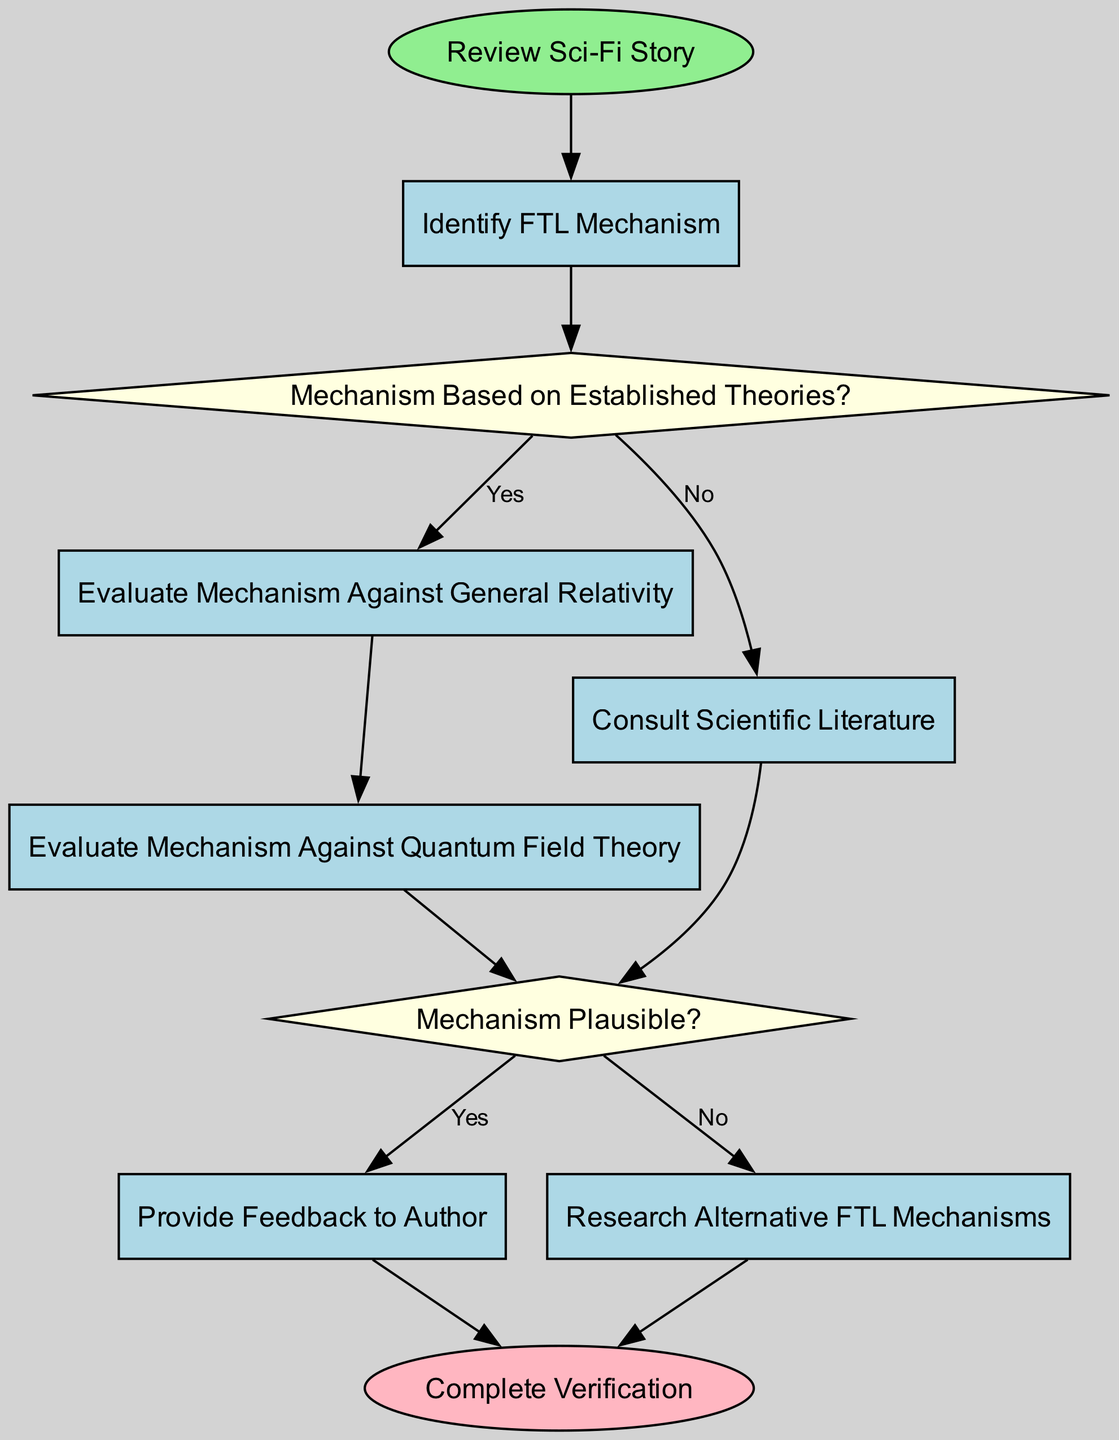What is the first activity in the diagram? The diagram starts with the node labeled "Review Sci-Fi Story". This is identified as the first element in the flow of the diagram.
Answer: Review Sci-Fi Story How many activities are present in the diagram? There are five activities in total: "Identify FTL Mechanism", "Evaluate Mechanism Against General Relativity", "Evaluate Mechanism Against Quantum Field Theory", "Consult Scientific Literature", and "Provide Feedback to Author".
Answer: Five What decision follows the identification of the FTL mechanism? After identifying the FTL mechanism, the next decision is "Mechanism Based on Established Theories?". This decision point is crucial for evaluating the established scientific foundations of the mechanism.
Answer: Mechanism Based on Established Theories? Which activity is reached if the mechanism is deemed plausible? If the mechanism is found to be plausible, the flow directs to the activity "Provide Feedback to Author". This indicates that the verification process allows for positive reinforcement.
Answer: Provide Feedback to Author If the mechanism is not based on established theories, which activity follows? If the mechanism is not based on established theories, the flow goes to "Consult Scientific Literature". This indicates a need for additional information before moving on to plausibility.
Answer: Consult Scientific Literature What is the final event of the verification process? The last event in the verification process is labeled "Complete Verification". This signifies that all necessary evaluations and feedback are finished.
Answer: Complete Verification What happens after evaluating the mechanism against general relativity? After evaluating the mechanism against general relativity, the next activity is "Evaluate Mechanism Against Quantum Field Theory", indicating a continuation of the assessment.
Answer: Evaluate Mechanism Against Quantum Field Theory What decision is made after consulting scientific literature? Following the consultation of scientific literature, the decision made is "Mechanism Plausible?". This decision determines the next steps based on the gathered evidence.
Answer: Mechanism Plausible? What should be done if the mechanism is not plausible? If the mechanism is not plausible, the next action is to "Research Alternative FTL Mechanisms", indicating a search for other potential FTL concepts.
Answer: Research Alternative FTL Mechanisms 